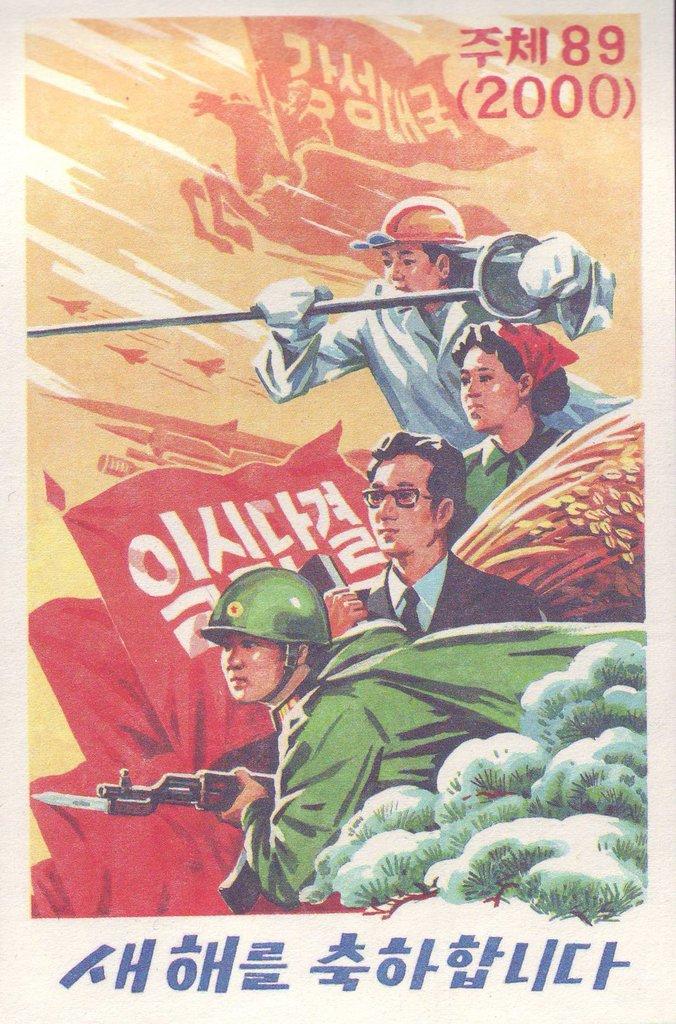What year is shown on this photo?
Give a very brief answer. 2000. 